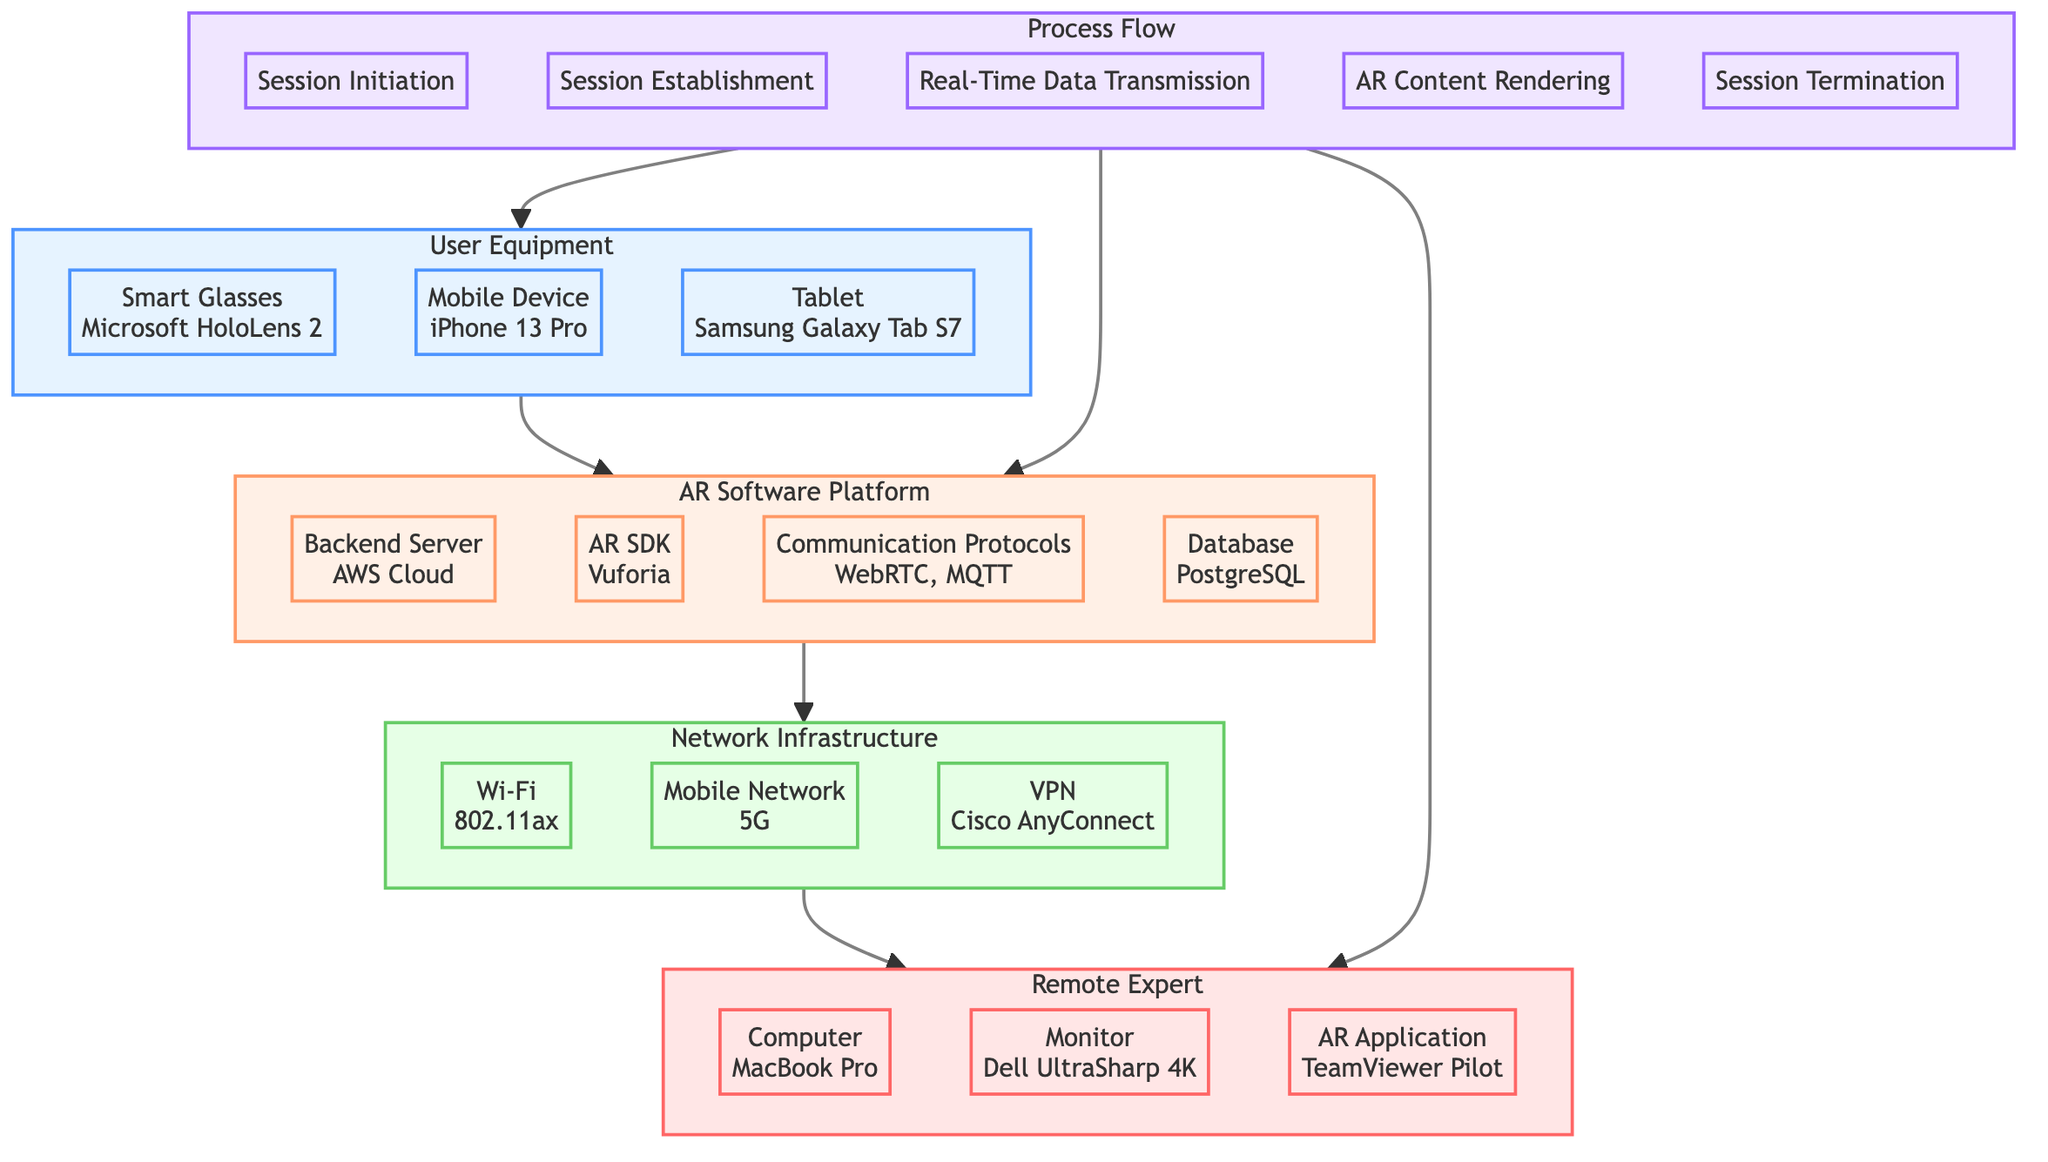What are the types of User Equipment used in the system? The diagram lists three types of User Equipment: Smart Glasses, Mobile Device, and Tablet. These are specifically mentioned under the "User Equipment" node.
Answer: Smart Glasses, Mobile Device, Tablet What is the communication protocol used? Within the "AR Software Platform" section of the diagram, "WebRTC" and "MQTT" are identified as the communication protocols.
Answer: WebRTC, MQTT How many components are there in the Remote Expert section? The diagram displays three components under the "Remote Expert" section, namely Computer, Monitor, and AR Application. By counting these, we determine the total.
Answer: 3 What happens during the Session Termination phase? The diagram indicates that during the "Session Termination" phase, the expert ends the session, and data is logged and stored. The answer can be drawn directly from the "Process Flow" section.
Answer: Expert ends session, data is logged & stored Which device is used as the Backend Server? The "AR Software Platform" section specifies that the Backend Server is "AWS Cloud." This is a direct reference in the diagram.
Answer: AWS Cloud What is the function of the AR SDK? The diagram designates the AR SDK as "Vuforia," which identifies the specific SDK used for augmented reality in the platform.
Answer: Vuforia What flows from User Equipment to AR Software Platform? The diagram illustrates an arrow from "User Equipment" to "AR Software Platform," indicating that the initial assistance request flows from the user equipment to the software platform.
Answer: Assistance request How is Real-Time Data Transmission achieved? According to the "Process Flow" section, Real-Time Data Transmission is achieved through "Streaming over WebRTC." This detail is captured under the connectivity processes depicted in the diagram.
Answer: Streaming over WebRTC What is the role of the Database in the AR Software Platform? The database, specified as "PostgreSQL," is part of the backend structure that likely supports data storage, retrieval, and management for the application as grouped under the AR Software Platform.
Answer: Data storage, retrieval & management 